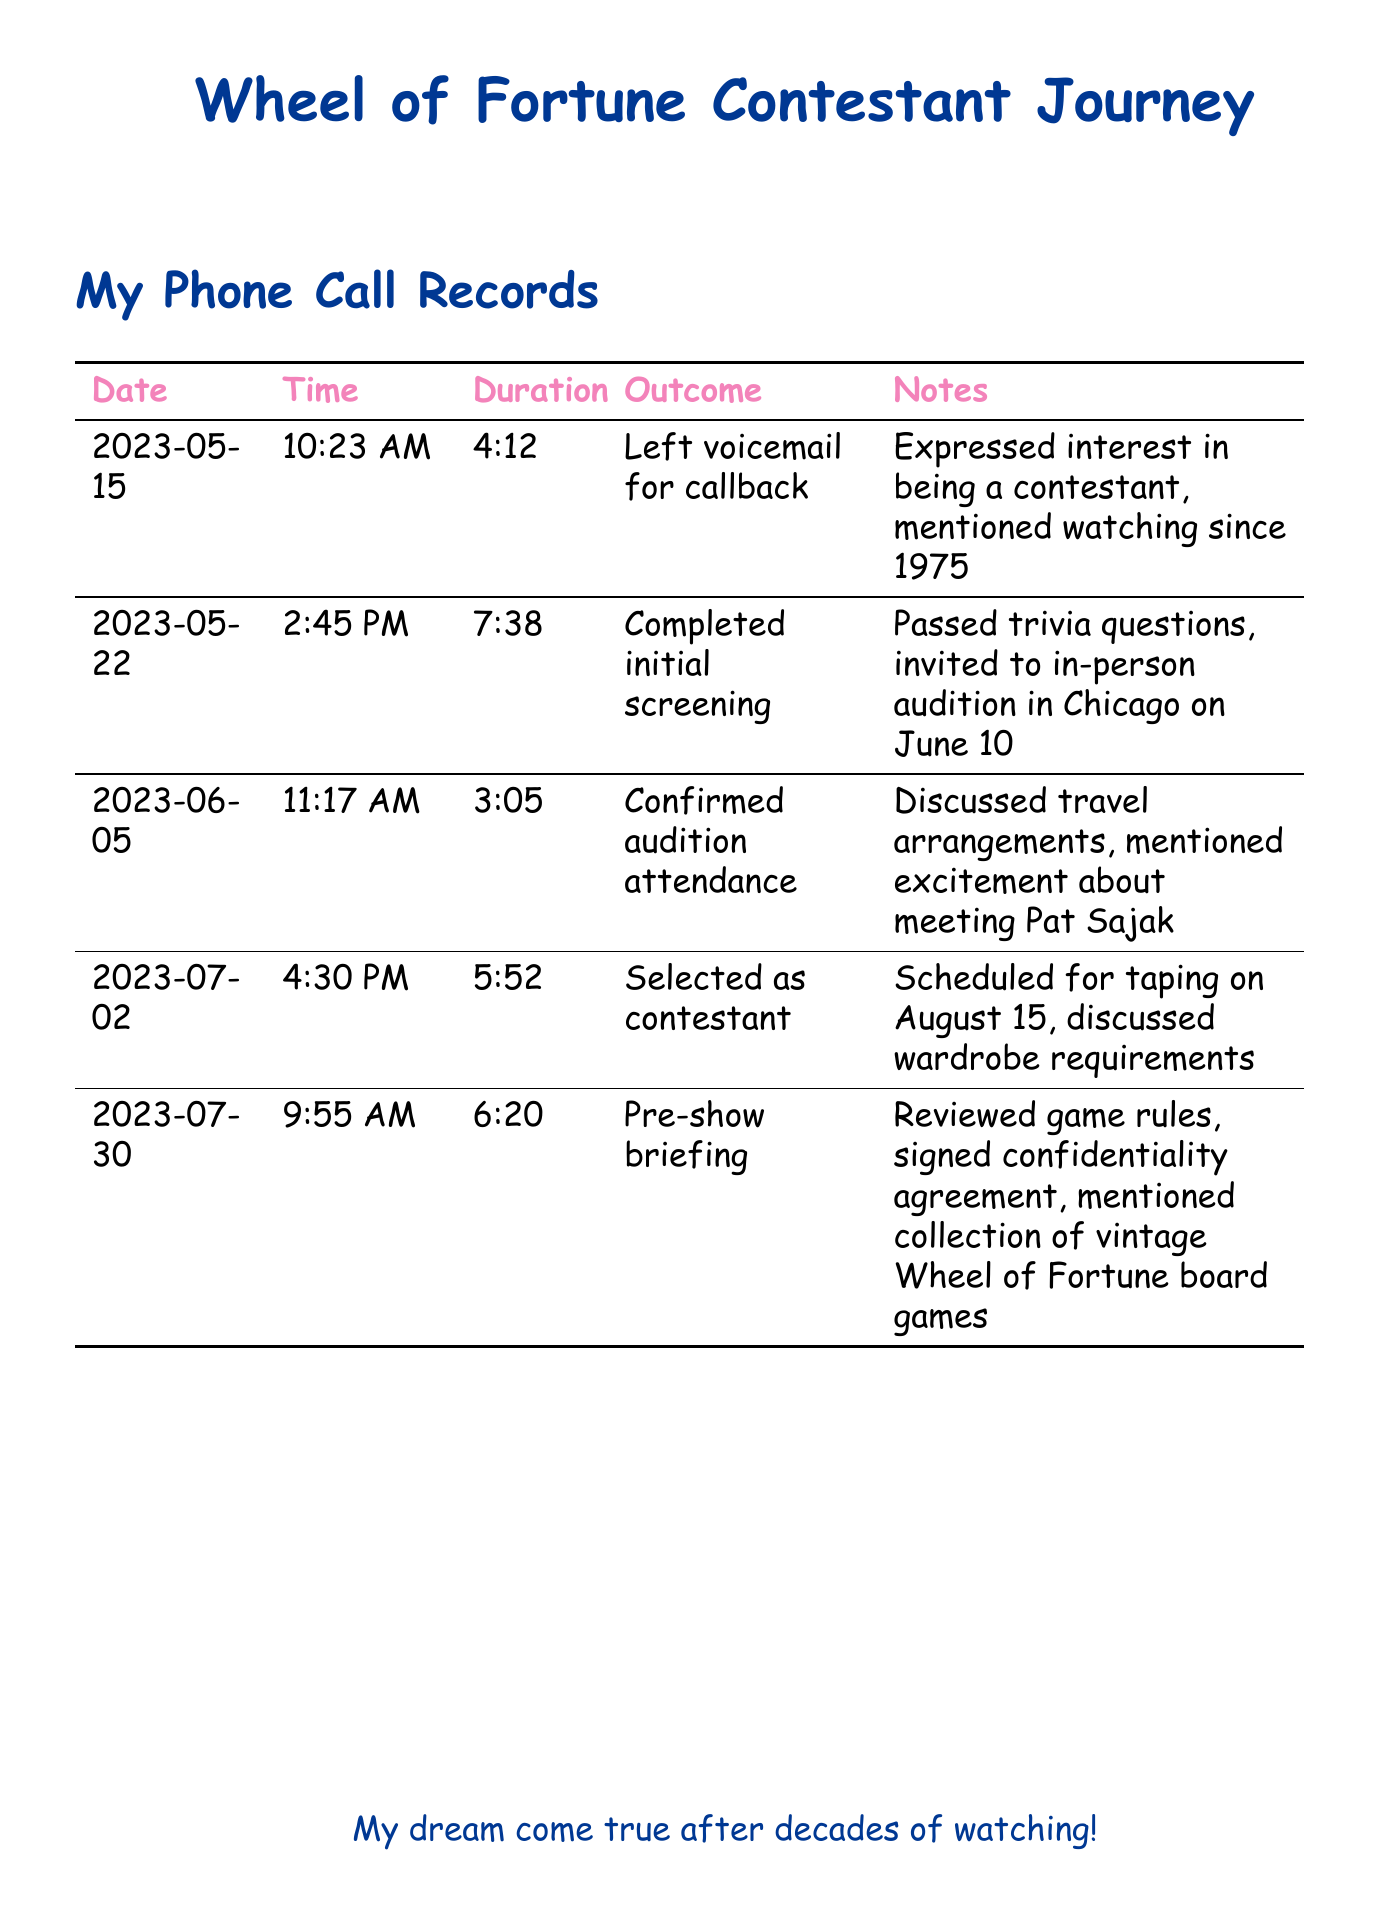What date was the first call made? The first call was made on May 15, 2023, as shown in the records.
Answer: May 15, 2023 What was the outcome of the call on July 2? The outcome of the call on July 2 was selecting the contestant, which is indicated in the document.
Answer: Selected as contestant How long was the voicemail left on the first call? The duration of the voicemail left on the first call was 4 minutes and 12 seconds.
Answer: 4:12 On which date is the taping scheduled? The taping is scheduled for August 15, which can be found in the notes of the call on July 2.
Answer: August 15 How many minutes did the pre-show briefing last? The pre-show briefing lasted 6 minutes and 20 seconds, as detailed in the records.
Answer: 6:20 What note was mentioned during the pre-show briefing? The note mentioned during the pre-show briefing was about reviewing game rules and signing a confidentiality agreement.
Answer: Reviewed game rules What was discussed on June 5? Travel arrangements were discussed on June 5, along with excitement about Pat Sajak.
Answer: Travel arrangements What time was the initial screening call made? The initial screening call was made at 2:45 PM, as indicated in the document.
Answer: 2:45 PM 